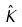<formula> <loc_0><loc_0><loc_500><loc_500>\hat { K }</formula> 